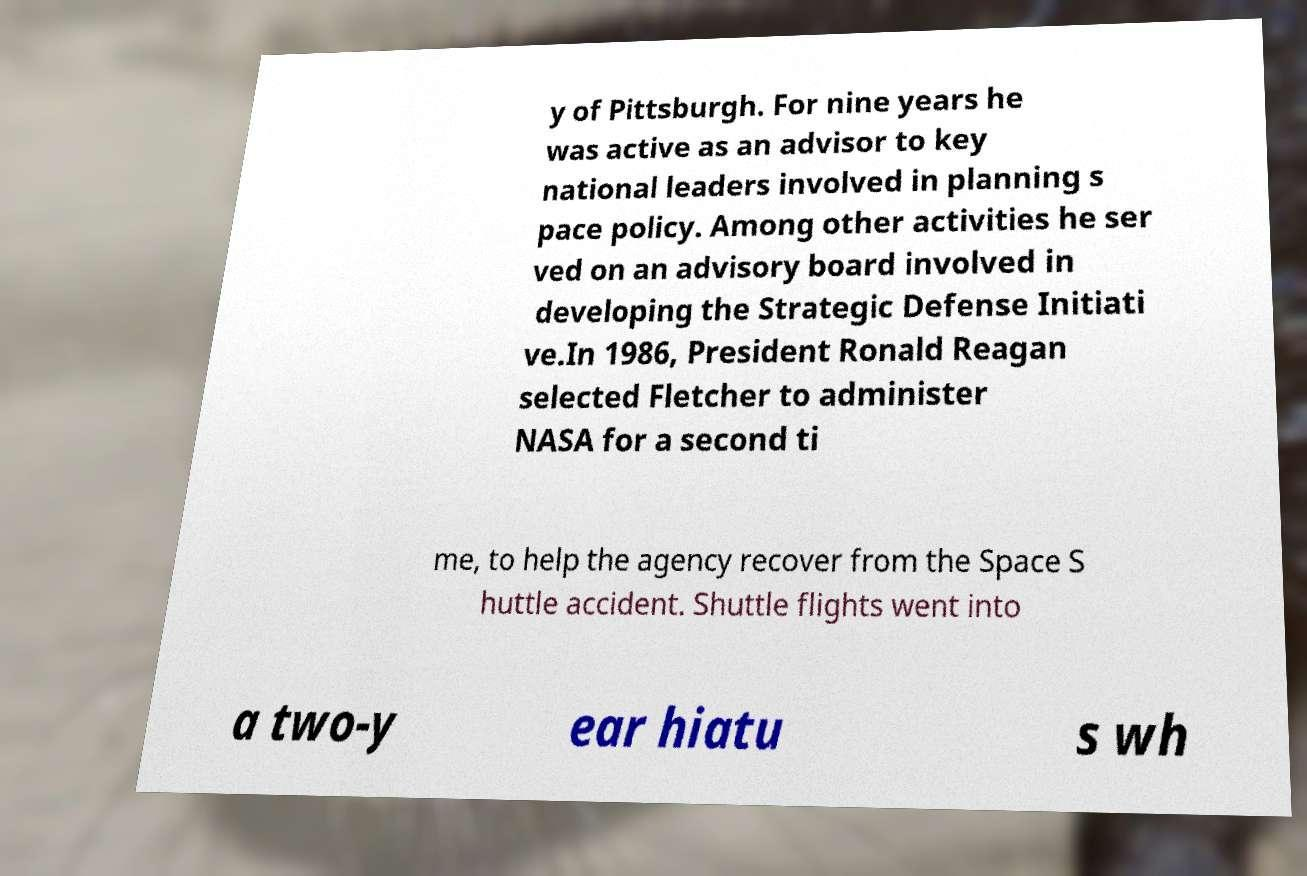Please read and relay the text visible in this image. What does it say? y of Pittsburgh. For nine years he was active as an advisor to key national leaders involved in planning s pace policy. Among other activities he ser ved on an advisory board involved in developing the Strategic Defense Initiati ve.In 1986, President Ronald Reagan selected Fletcher to administer NASA for a second ti me, to help the agency recover from the Space S huttle accident. Shuttle flights went into a two-y ear hiatu s wh 